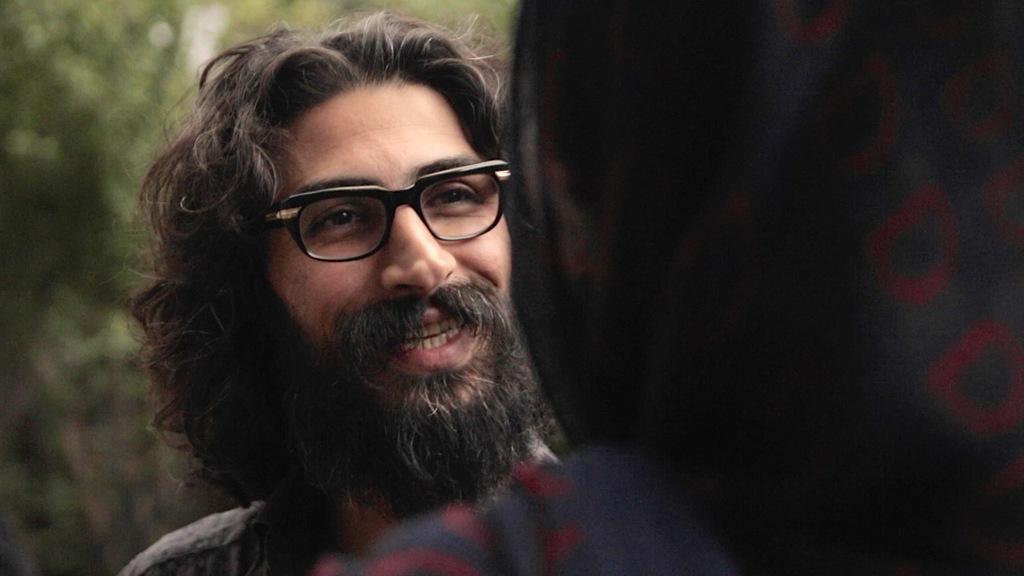Can you describe this image briefly? In this image, I can see the man smiling. The background looks green in color. On the right side of the image, I think this is a person. 